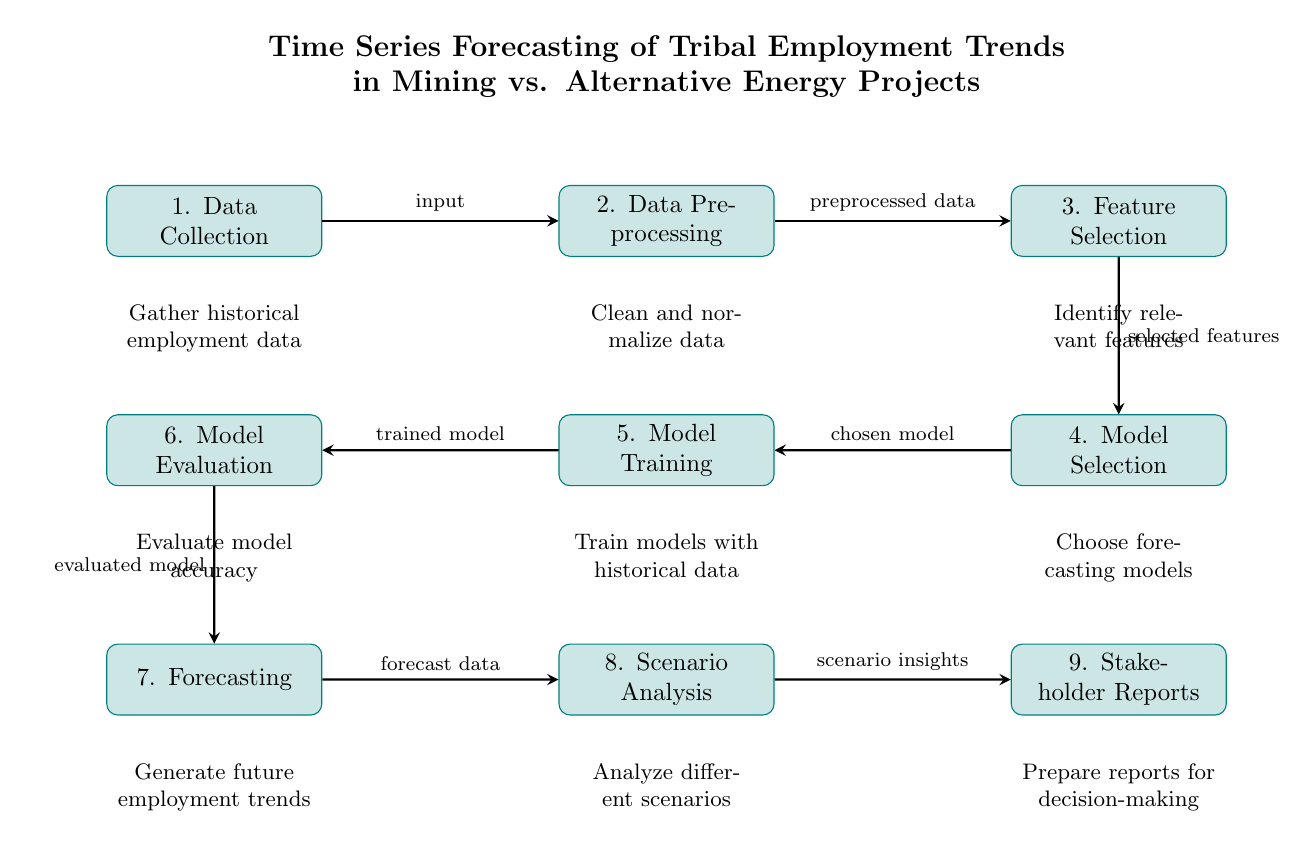What is the title of the diagram? The title of the diagram is presented at the top and indicates the overall focus of the analysis, detailing the subject matter of the diagram. It reads, "Time Series Forecasting of Tribal Employment Trends in Mining vs. Alternative Energy Projects."
Answer: Time Series Forecasting of Tribal Employment Trends in Mining vs. Alternative Energy Projects How many main process nodes are there in the diagram? The diagram contains a total of nine main process nodes, each representing a step in the time series forecasting process.
Answer: 9 What follows 'Model Evaluation' in the diagram? The flow of the diagram shows that 'Model Evaluation' connects to 'Forecasting', which is the next step in the process.
Answer: Forecasting What type of insights does 'Scenario Analysis' provide? 'Scenario Analysis' provides insights based on different forecasts and models to prepare for various potential outcomes in employment trends.
Answer: scenario insights What is the input that starts the process in the diagram? The input that starts the diagram is 'Data Collection,' which begins the workflow of the time series forecasting process by gathering necessary data.
Answer: Data Collection Which process directly precedes 'Stakeholder Reports'? The process that directly precedes 'Stakeholder Reports' is 'Scenario Analysis,' indicating that the insights gained from this analysis are presented in the reports.
Answer: Scenario Analysis What is the main action performed in the 'Model Training' step? In 'Model Training,' the action performed is to train models with the historical data that was collected and preprocessed.
Answer: Train models with historical data What is the purpose of 'Feature Selection'? The purpose of 'Feature Selection' is to identify relevant features that will contribute meaningfully to the forecasting model, improving its predictive capabilities.
Answer: Identify relevant features How is 'Model Selection' related to 'Model Training'? 'Model Selection' is related to 'Model Training' as it involves choosing the appropriate forecasting models that will then be trained in the subsequent step.
Answer: Chosen model 